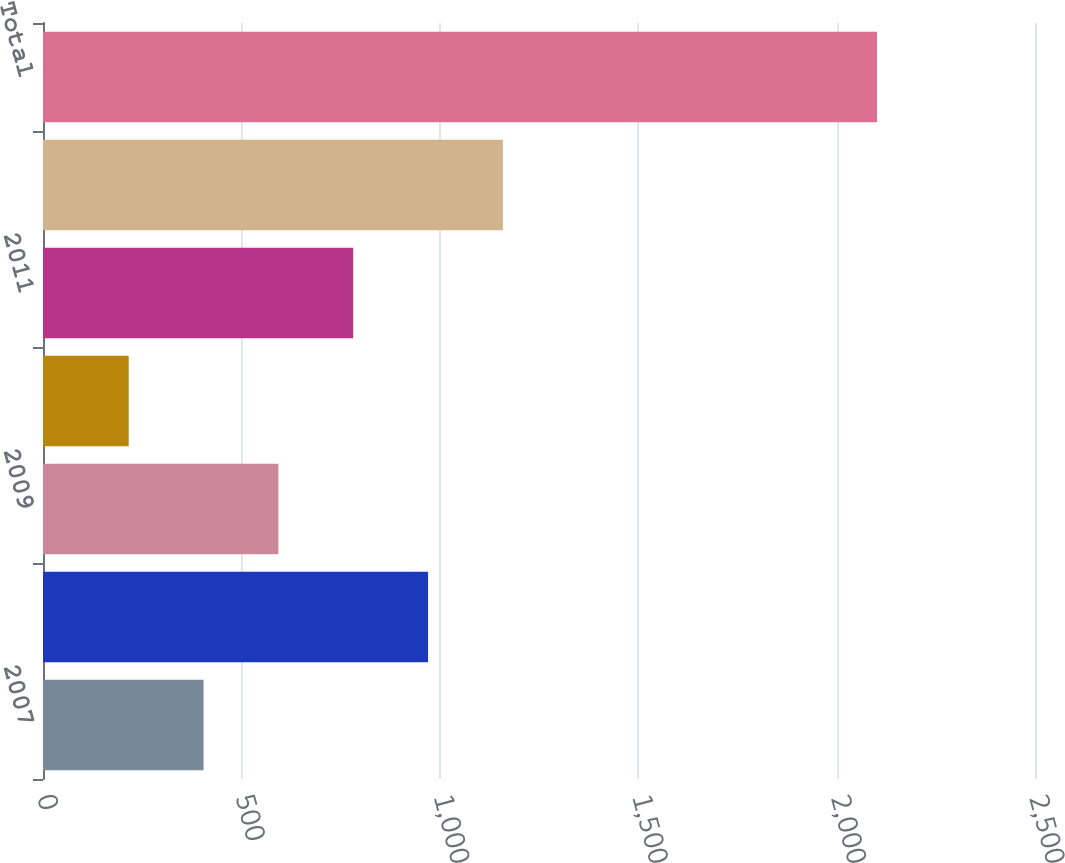Convert chart. <chart><loc_0><loc_0><loc_500><loc_500><bar_chart><fcel>2007<fcel>2008<fcel>2009<fcel>2010<fcel>2011<fcel>2012-2015<fcel>Total<nl><fcel>404.6<fcel>970.4<fcel>593.2<fcel>216<fcel>781.8<fcel>1159<fcel>2102<nl></chart> 